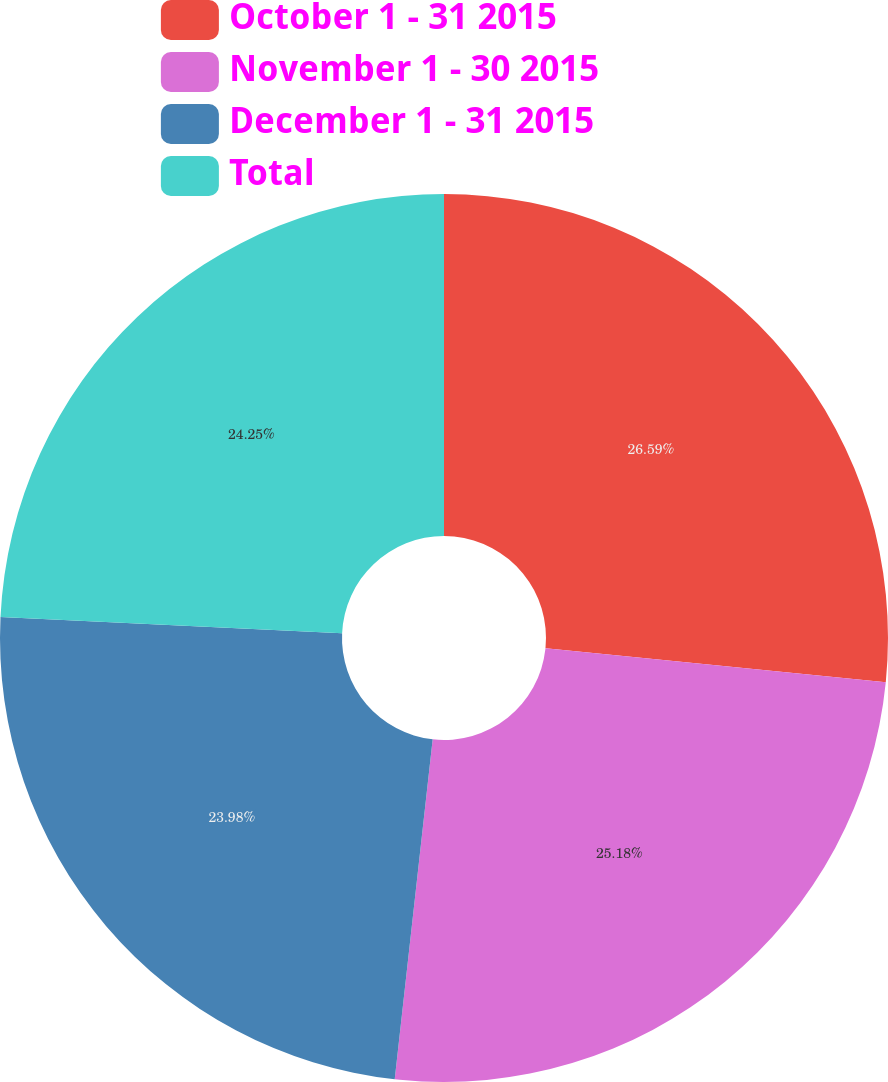Convert chart. <chart><loc_0><loc_0><loc_500><loc_500><pie_chart><fcel>October 1 - 31 2015<fcel>November 1 - 30 2015<fcel>December 1 - 31 2015<fcel>Total<nl><fcel>26.59%<fcel>25.18%<fcel>23.98%<fcel>24.25%<nl></chart> 